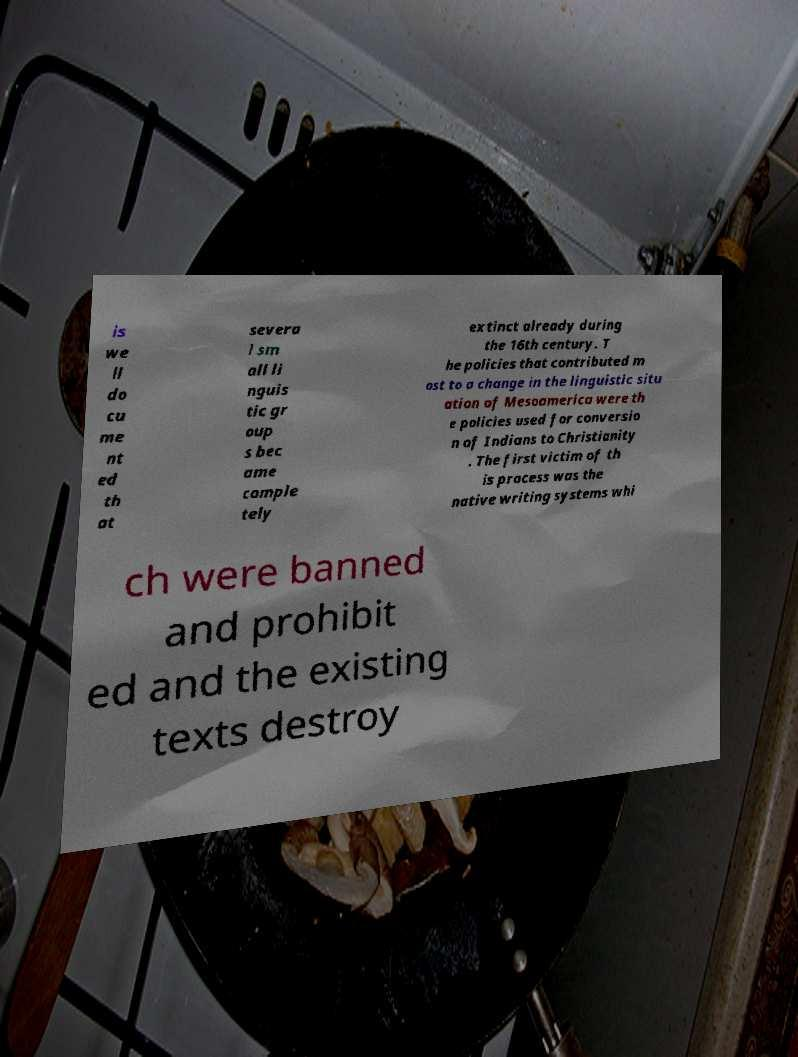Please read and relay the text visible in this image. What does it say? is we ll do cu me nt ed th at severa l sm all li nguis tic gr oup s bec ame comple tely extinct already during the 16th century. T he policies that contributed m ost to a change in the linguistic situ ation of Mesoamerica were th e policies used for conversio n of Indians to Christianity . The first victim of th is process was the native writing systems whi ch were banned and prohibit ed and the existing texts destroy 